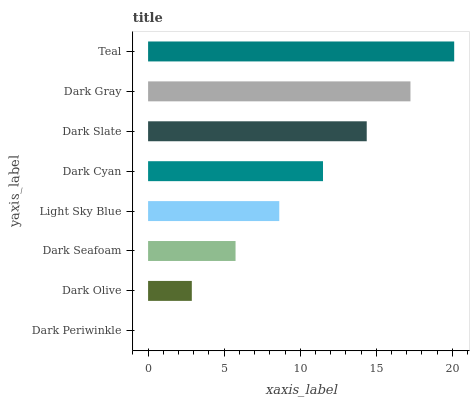Is Dark Periwinkle the minimum?
Answer yes or no. Yes. Is Teal the maximum?
Answer yes or no. Yes. Is Dark Olive the minimum?
Answer yes or no. No. Is Dark Olive the maximum?
Answer yes or no. No. Is Dark Olive greater than Dark Periwinkle?
Answer yes or no. Yes. Is Dark Periwinkle less than Dark Olive?
Answer yes or no. Yes. Is Dark Periwinkle greater than Dark Olive?
Answer yes or no. No. Is Dark Olive less than Dark Periwinkle?
Answer yes or no. No. Is Dark Cyan the high median?
Answer yes or no. Yes. Is Light Sky Blue the low median?
Answer yes or no. Yes. Is Dark Slate the high median?
Answer yes or no. No. Is Dark Periwinkle the low median?
Answer yes or no. No. 